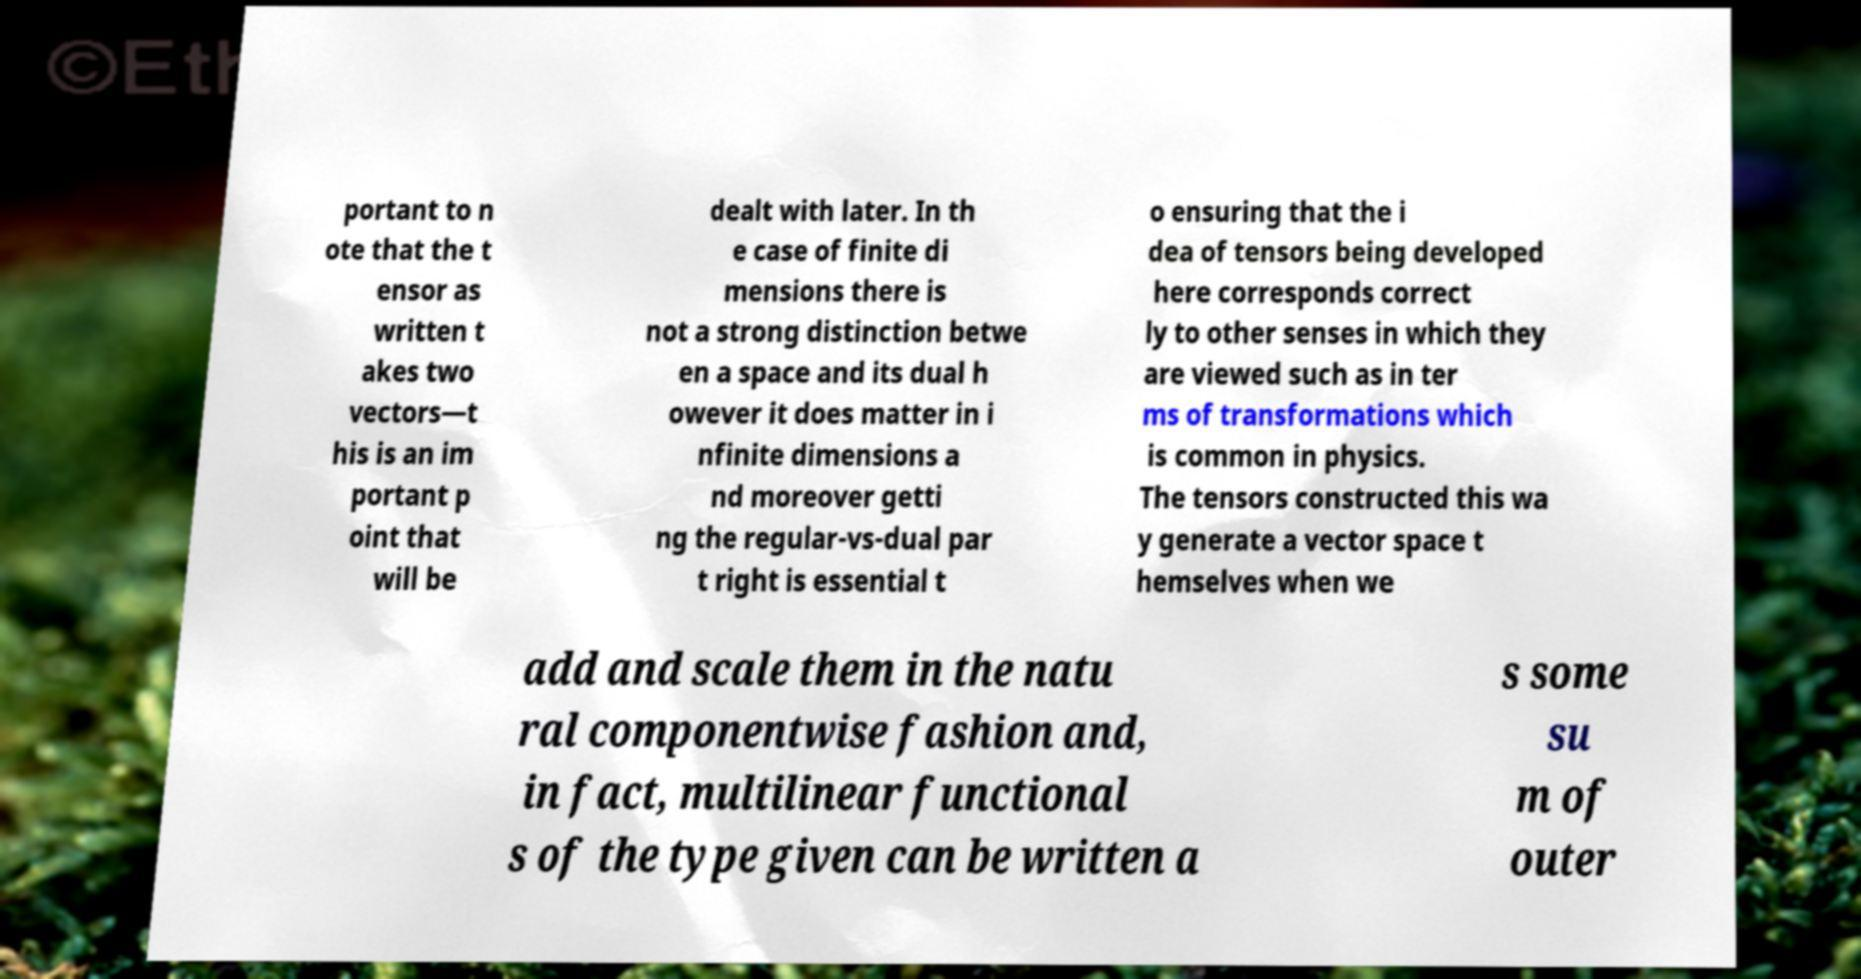There's text embedded in this image that I need extracted. Can you transcribe it verbatim? portant to n ote that the t ensor as written t akes two vectors—t his is an im portant p oint that will be dealt with later. In th e case of finite di mensions there is not a strong distinction betwe en a space and its dual h owever it does matter in i nfinite dimensions a nd moreover getti ng the regular-vs-dual par t right is essential t o ensuring that the i dea of tensors being developed here corresponds correct ly to other senses in which they are viewed such as in ter ms of transformations which is common in physics. The tensors constructed this wa y generate a vector space t hemselves when we add and scale them in the natu ral componentwise fashion and, in fact, multilinear functional s of the type given can be written a s some su m of outer 